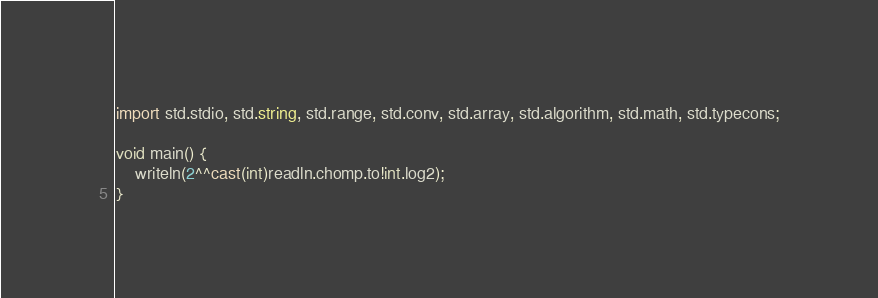<code> <loc_0><loc_0><loc_500><loc_500><_D_>import std.stdio, std.string, std.range, std.conv, std.array, std.algorithm, std.math, std.typecons;

void main() {
    writeln(2^^cast(int)readln.chomp.to!int.log2);
}

</code> 